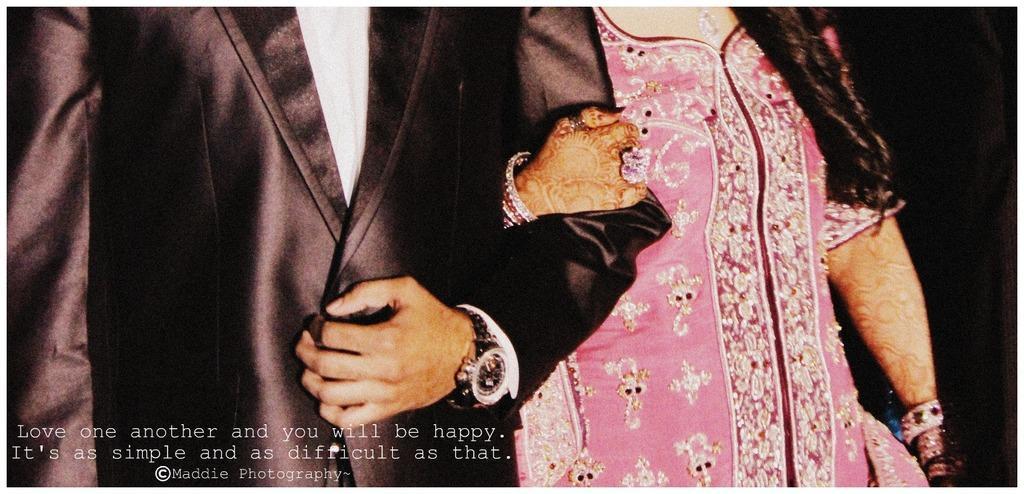In one or two sentences, can you explain what this image depicts? In this picture I can see a man and a woman are standing together. The man is wearing suit and a watch. The woman is wearing pink color dress. 